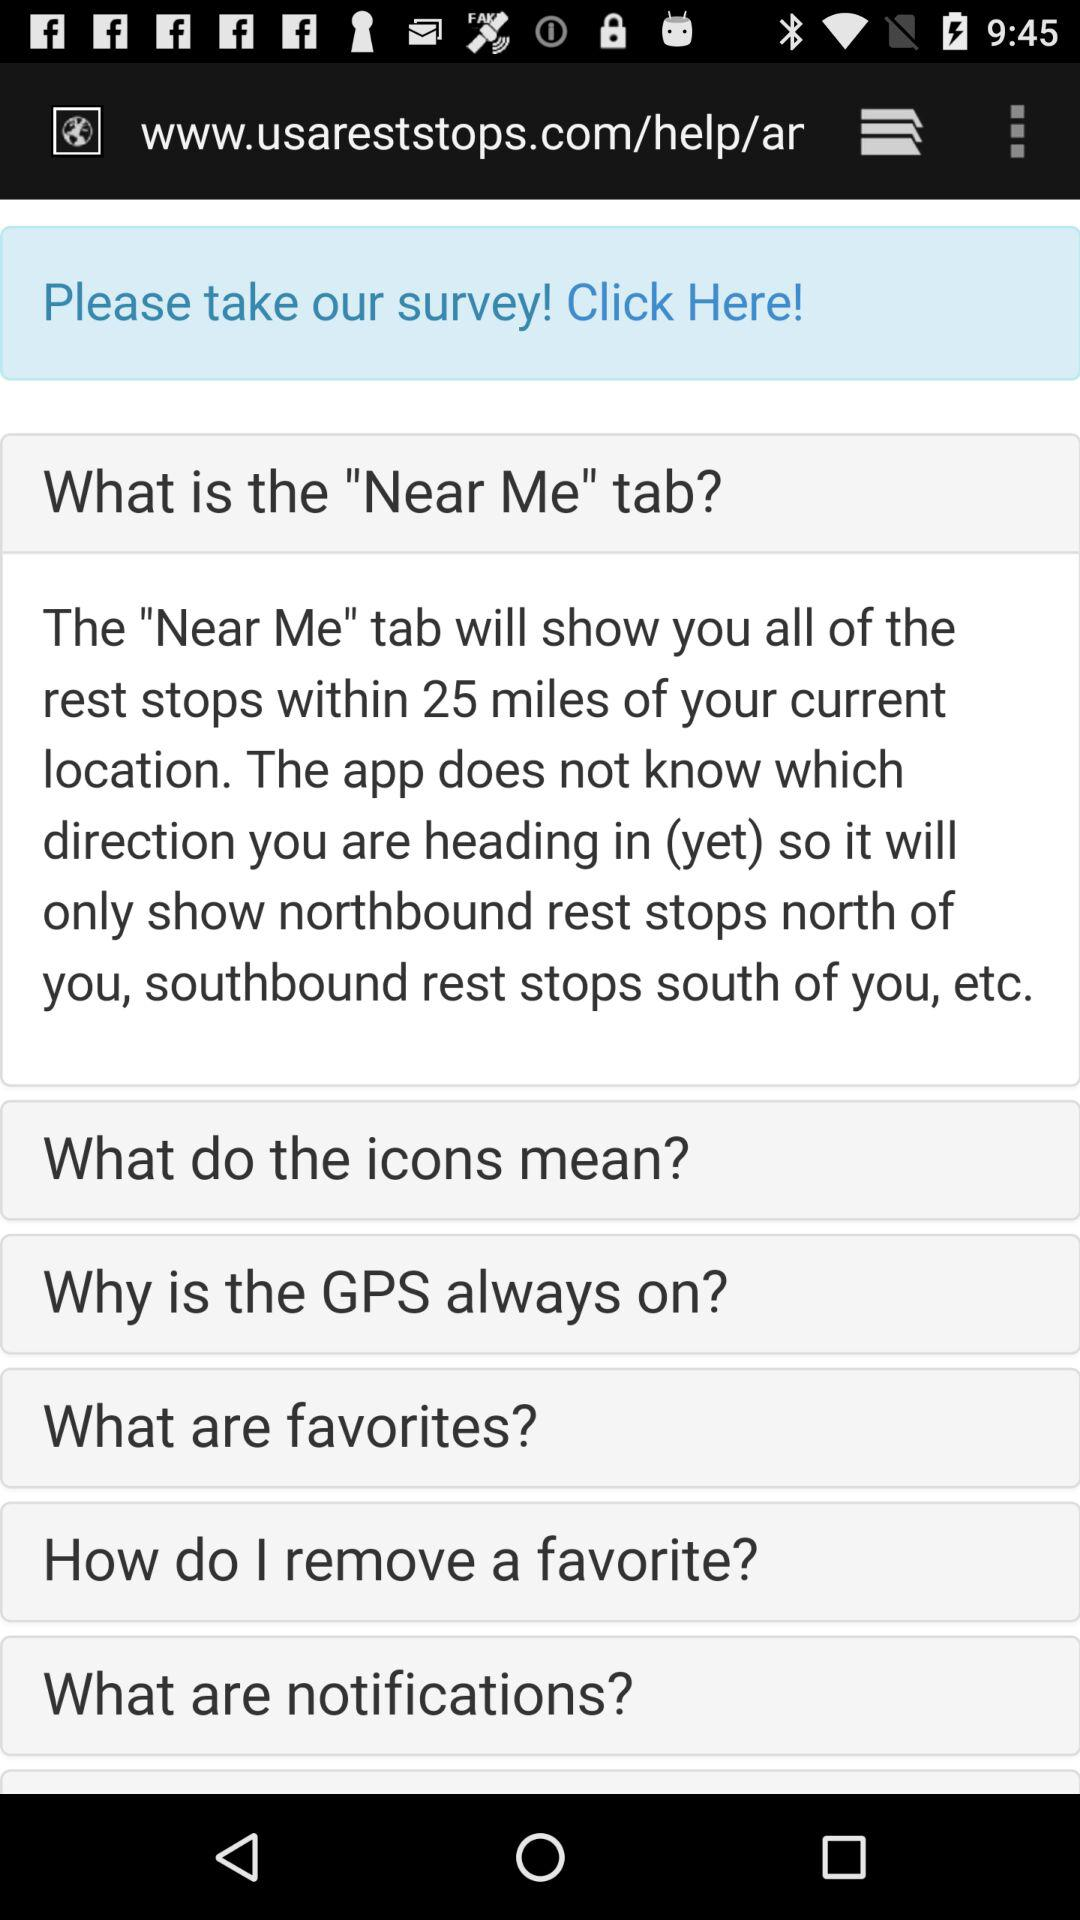What is the name of application?
When the provided information is insufficient, respond with <no answer>. <no answer> 